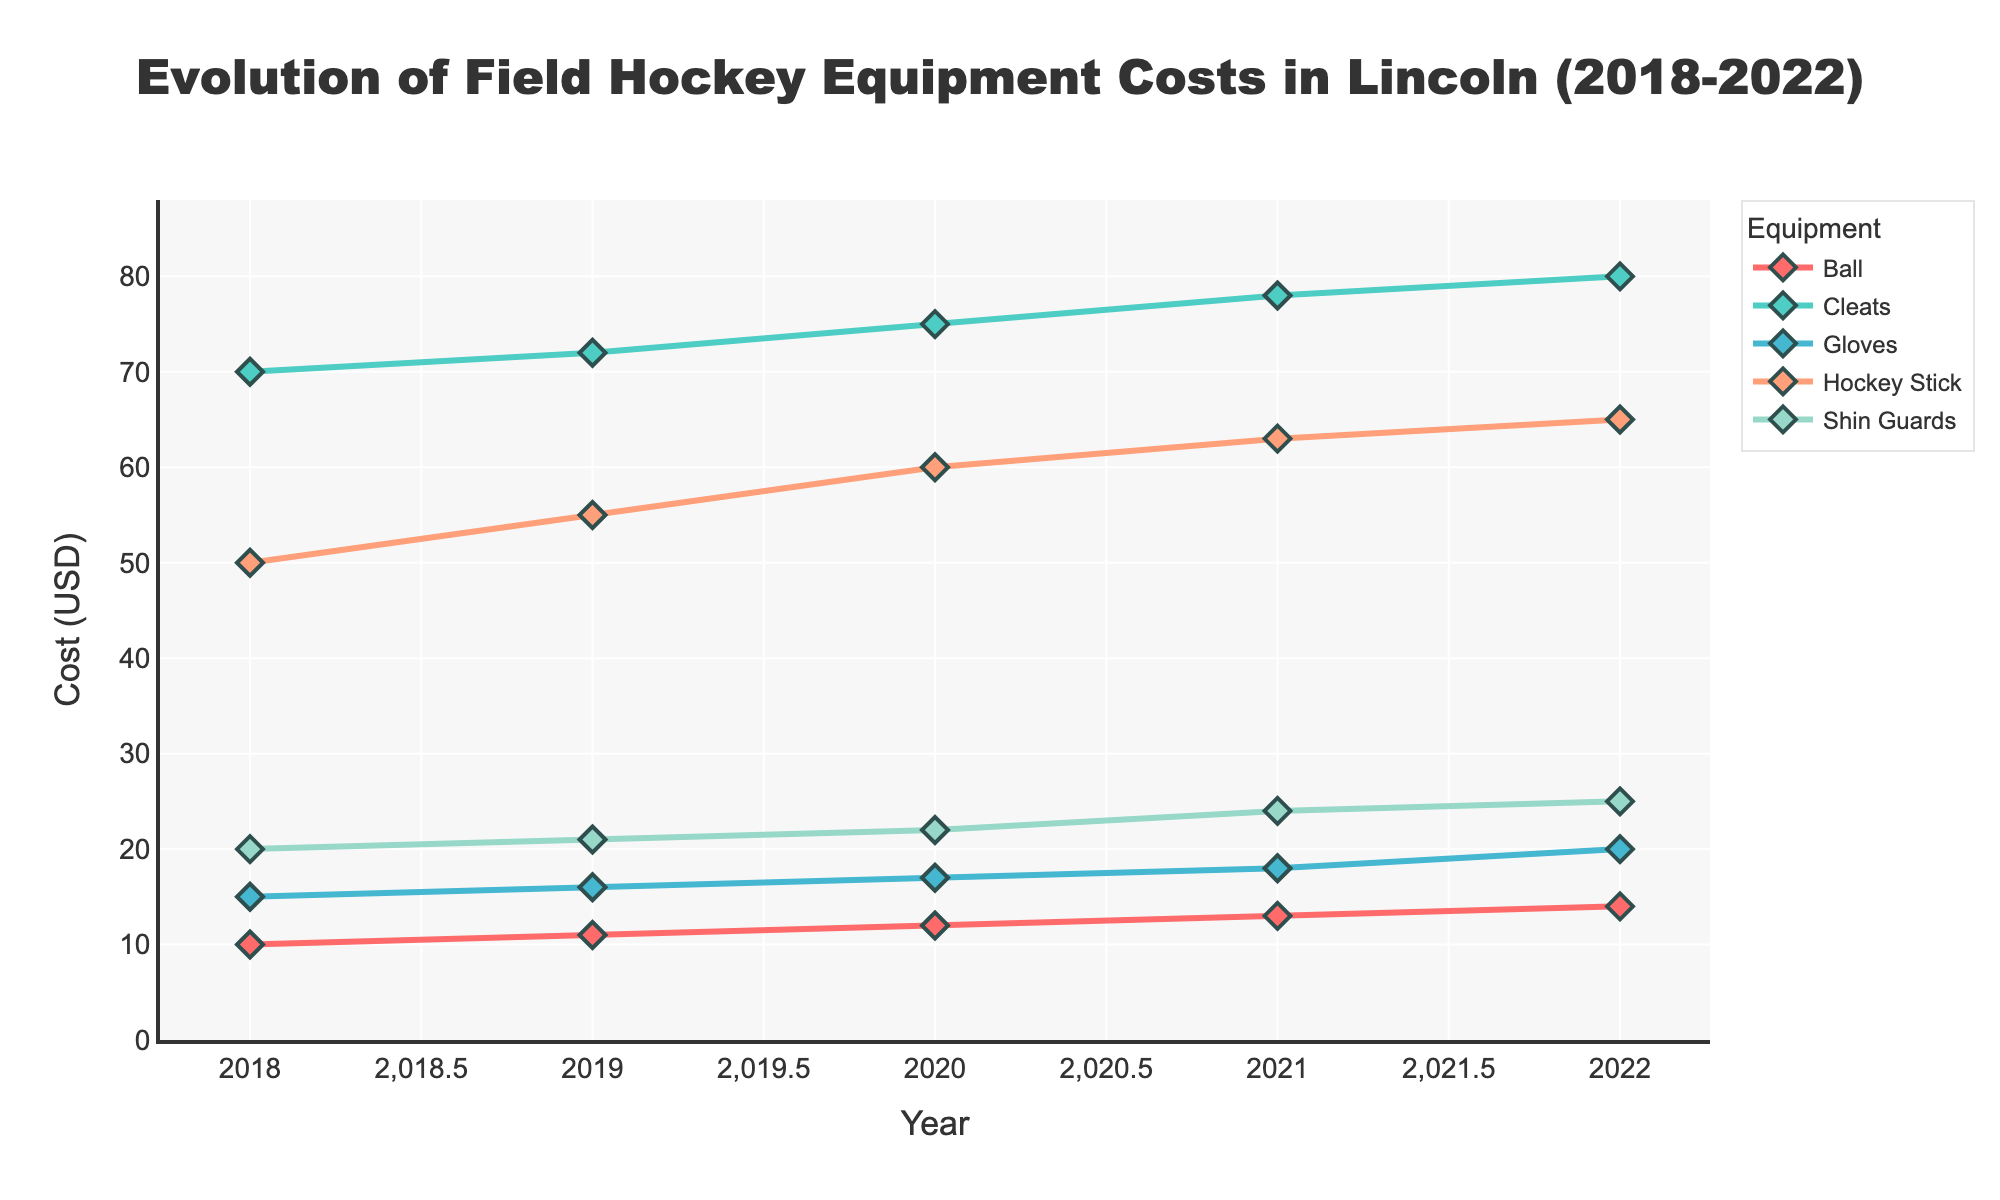What is the title of the plot? The title is positioned at the top center of the plot and is designed to provide a quick understanding of what the data represents.
Answer: Evolution of Field Hockey Equipment Costs in Lincoln (2018-2022) What does the y-axis represent? The y-axis typically indicates the measure being tracked over time. In this plot, the y-axis shows the cost in USD.
Answer: Cost (USD) What is the trend of the cost for hockey sticks from 2018 to 2022? To determine the trend, observe the line corresponding to hockey sticks and note the changes over the years. The cost increases each year.
Answer: Increasing Which piece of equipment had the lowest cost in 2022? To find the lowest cost equipment in 2022, look at the data points for each piece of equipment for that year.
Answer: Ball How much did the cost of shin guards change from 2018 to 2022? Calculate the difference between the cost in 2022 and the cost in 2018 for shin guards: 25 - 20.
Answer: 5 USD In which year did gloves see the highest increase in cost compared to the previous year? Compare the year-over-year changes for gloves between consecutive years to identify the highest increase. From 2021 to 2022, the cost increased by 2 USD.
Answer: 2022 Which piece of equipment had the least change in cost over the five years? Calculate the difference between the 2022 and 2018 costs for each equipment. The ball had the least change, with an increase of 4 USD.
Answer: Ball How does the cost of cleats in 2019 compare to 2020? Compare the y-values for cleats in 2019 and 2020 directly. The cost increased from 72 USD in 2019 to 75 USD in 2020.
Answer: Increased What is the color used for the trace of shin guards? Identify the color associated with shin guards by observing the color of its line and markers. It is a turquoise-like color.
Answer: Turquoise-like Is there any year where all equipment costs increased compared to the previous year? Check each equipment's year-over-year data points to see if they all show an increase in any given year. All equipment costs increased annually.
Answer: Yes 